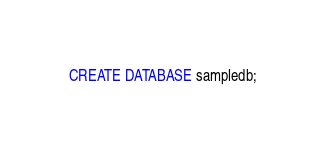Convert code to text. <code><loc_0><loc_0><loc_500><loc_500><_SQL_>CREATE DATABASE sampledb;
</code> 